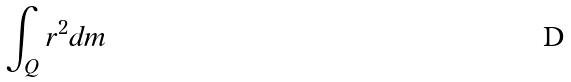<formula> <loc_0><loc_0><loc_500><loc_500>\int _ { Q } r ^ { 2 } d m</formula> 